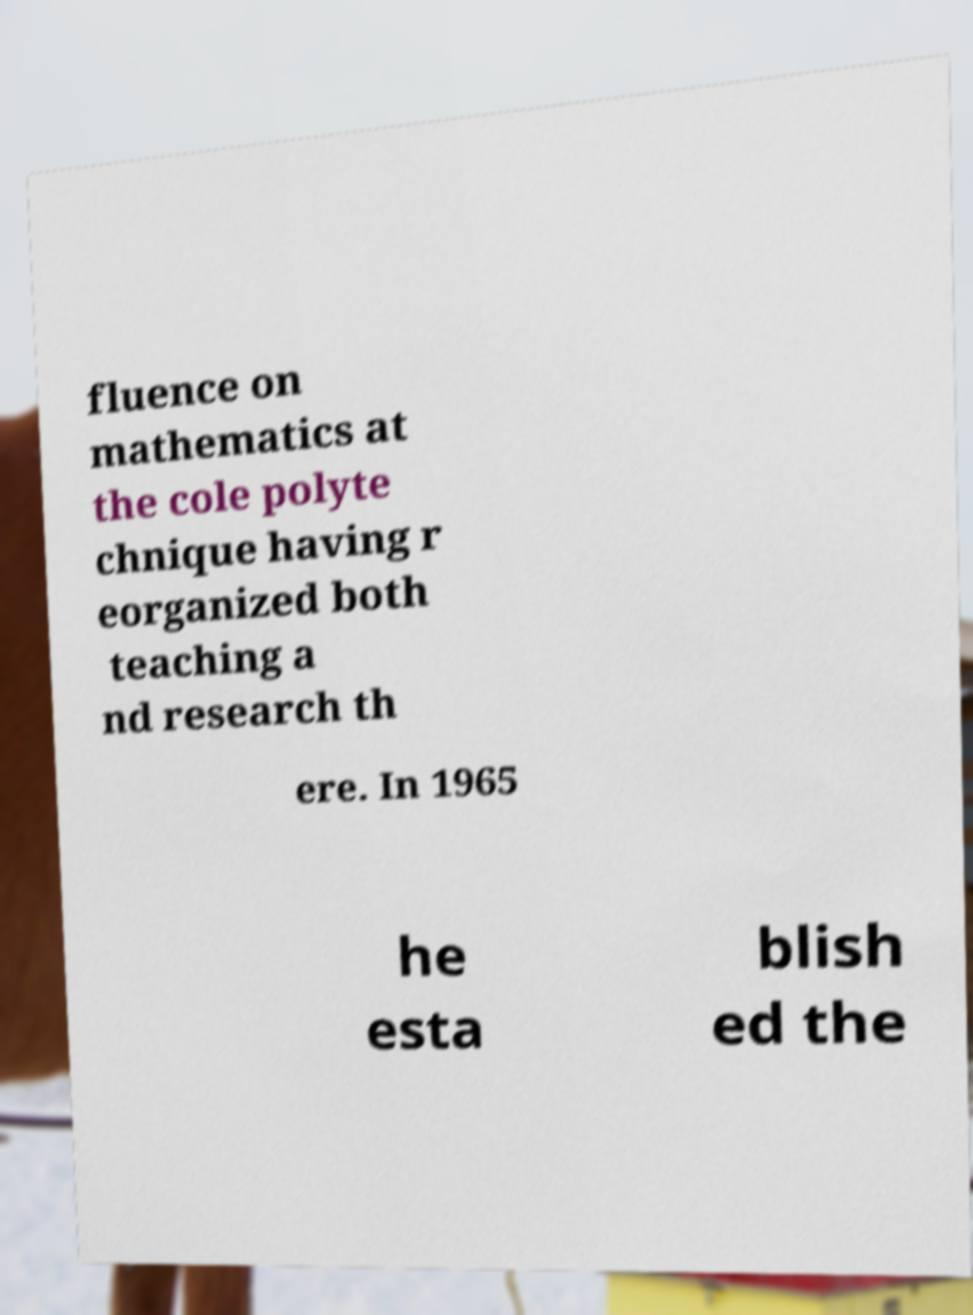Could you assist in decoding the text presented in this image and type it out clearly? fluence on mathematics at the cole polyte chnique having r eorganized both teaching a nd research th ere. In 1965 he esta blish ed the 